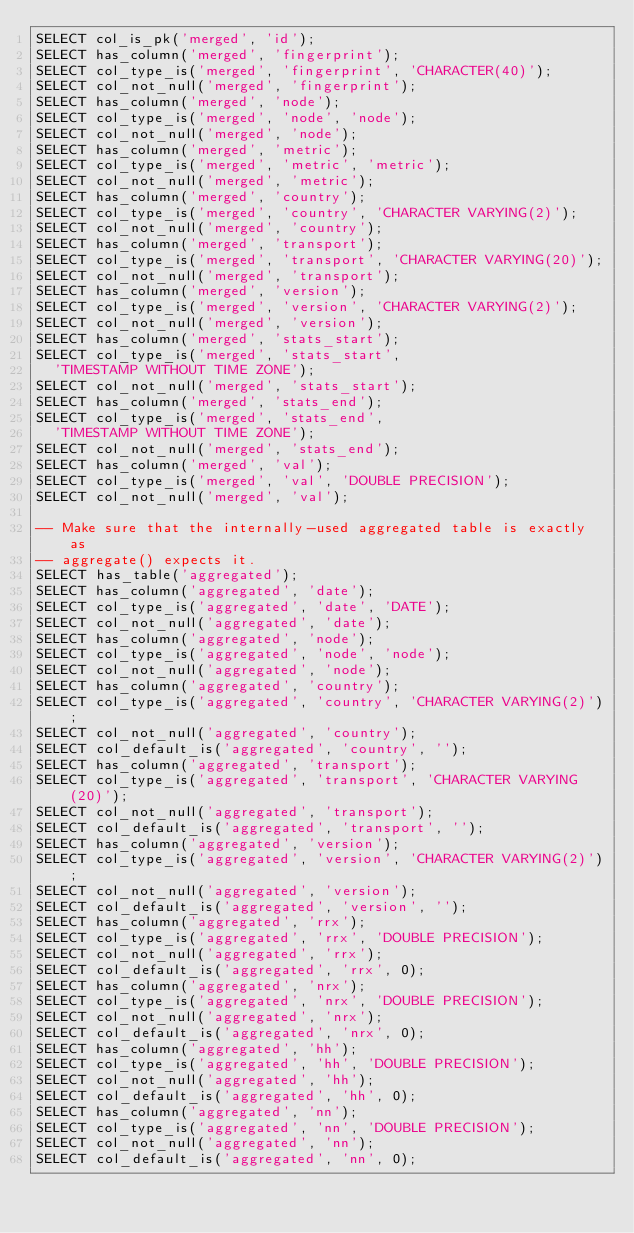Convert code to text. <code><loc_0><loc_0><loc_500><loc_500><_SQL_>SELECT col_is_pk('merged', 'id');
SELECT has_column('merged', 'fingerprint');
SELECT col_type_is('merged', 'fingerprint', 'CHARACTER(40)');
SELECT col_not_null('merged', 'fingerprint');
SELECT has_column('merged', 'node');
SELECT col_type_is('merged', 'node', 'node');
SELECT col_not_null('merged', 'node');
SELECT has_column('merged', 'metric');
SELECT col_type_is('merged', 'metric', 'metric');
SELECT col_not_null('merged', 'metric');
SELECT has_column('merged', 'country');
SELECT col_type_is('merged', 'country', 'CHARACTER VARYING(2)');
SELECT col_not_null('merged', 'country');
SELECT has_column('merged', 'transport');
SELECT col_type_is('merged', 'transport', 'CHARACTER VARYING(20)');
SELECT col_not_null('merged', 'transport');
SELECT has_column('merged', 'version');
SELECT col_type_is('merged', 'version', 'CHARACTER VARYING(2)');
SELECT col_not_null('merged', 'version');
SELECT has_column('merged', 'stats_start');
SELECT col_type_is('merged', 'stats_start',
  'TIMESTAMP WITHOUT TIME ZONE');
SELECT col_not_null('merged', 'stats_start');
SELECT has_column('merged', 'stats_end');
SELECT col_type_is('merged', 'stats_end',
  'TIMESTAMP WITHOUT TIME ZONE');
SELECT col_not_null('merged', 'stats_end');
SELECT has_column('merged', 'val');
SELECT col_type_is('merged', 'val', 'DOUBLE PRECISION');
SELECT col_not_null('merged', 'val');

-- Make sure that the internally-used aggregated table is exactly as
-- aggregate() expects it.
SELECT has_table('aggregated');
SELECT has_column('aggregated', 'date');
SELECT col_type_is('aggregated', 'date', 'DATE');
SELECT col_not_null('aggregated', 'date');
SELECT has_column('aggregated', 'node');
SELECT col_type_is('aggregated', 'node', 'node');
SELECT col_not_null('aggregated', 'node');
SELECT has_column('aggregated', 'country');
SELECT col_type_is('aggregated', 'country', 'CHARACTER VARYING(2)');
SELECT col_not_null('aggregated', 'country');
SELECT col_default_is('aggregated', 'country', '');
SELECT has_column('aggregated', 'transport');
SELECT col_type_is('aggregated', 'transport', 'CHARACTER VARYING(20)');
SELECT col_not_null('aggregated', 'transport');
SELECT col_default_is('aggregated', 'transport', '');
SELECT has_column('aggregated', 'version');
SELECT col_type_is('aggregated', 'version', 'CHARACTER VARYING(2)');
SELECT col_not_null('aggregated', 'version');
SELECT col_default_is('aggregated', 'version', '');
SELECT has_column('aggregated', 'rrx');
SELECT col_type_is('aggregated', 'rrx', 'DOUBLE PRECISION');
SELECT col_not_null('aggregated', 'rrx');
SELECT col_default_is('aggregated', 'rrx', 0);
SELECT has_column('aggregated', 'nrx');
SELECT col_type_is('aggregated', 'nrx', 'DOUBLE PRECISION');
SELECT col_not_null('aggregated', 'nrx');
SELECT col_default_is('aggregated', 'nrx', 0);
SELECT has_column('aggregated', 'hh');
SELECT col_type_is('aggregated', 'hh', 'DOUBLE PRECISION');
SELECT col_not_null('aggregated', 'hh');
SELECT col_default_is('aggregated', 'hh', 0);
SELECT has_column('aggregated', 'nn');
SELECT col_type_is('aggregated', 'nn', 'DOUBLE PRECISION');
SELECT col_not_null('aggregated', 'nn');
SELECT col_default_is('aggregated', 'nn', 0);</code> 